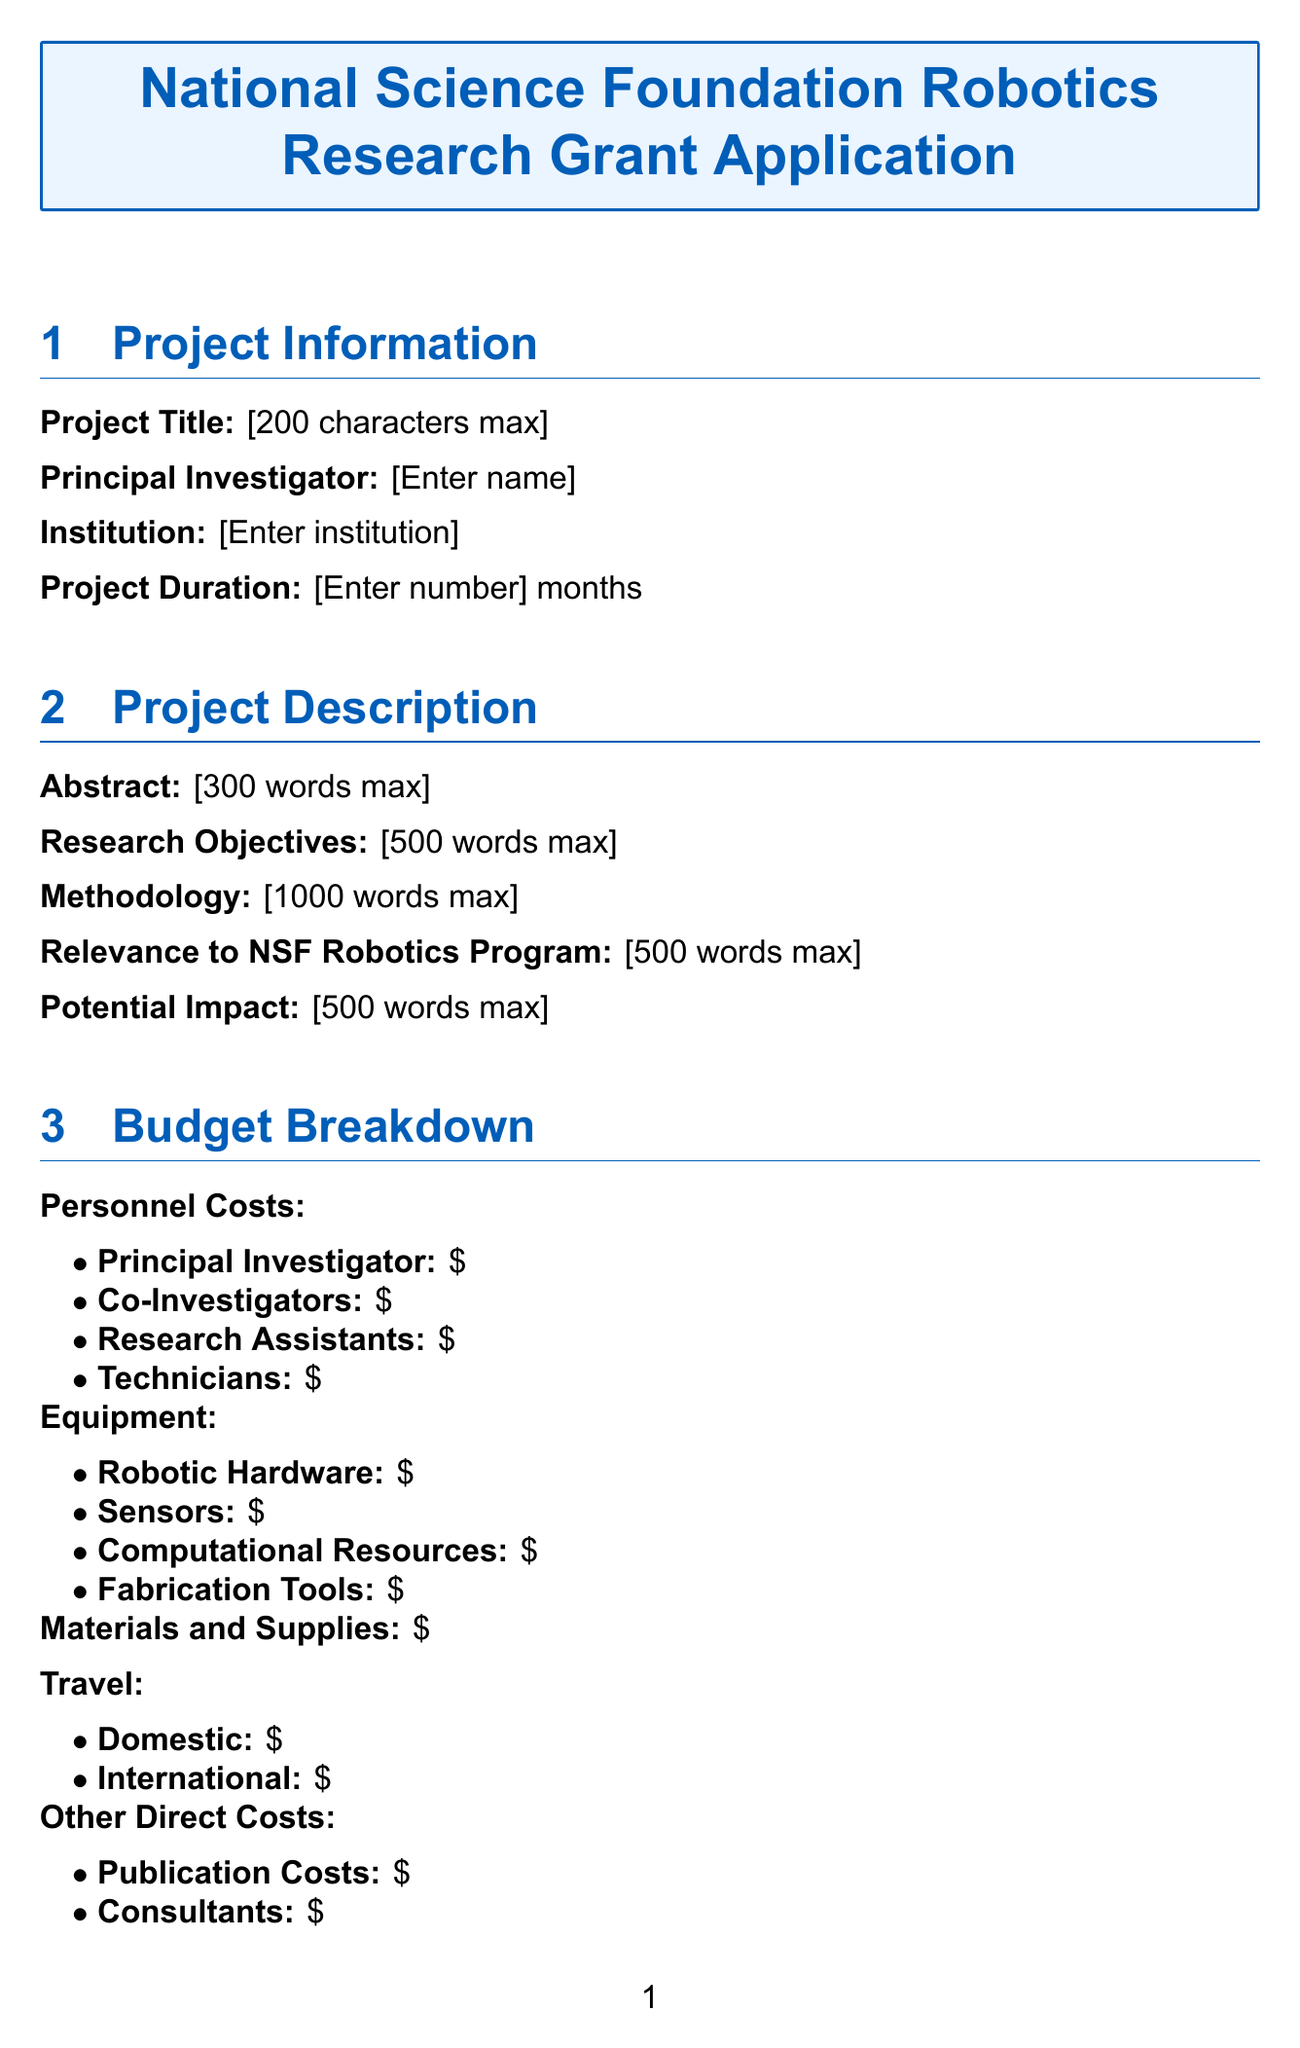what is the deadline for submission? The deadline for submission is indicated in the submission guidelines section.
Answer: September 15, 2023 what platform should the application be submitted on? The submission platform is mentioned in the submission guidelines section.
Answer: NSF FastLane System who is the principal investigator? The principal investigator's name is requested in the project information section.
Answer: [Enter name] how many months is the project duration? The project duration is requested as a number in the project information section.
Answer: [Enter number] what are the total budget requested calculations based on? The total budget requested is calculated based on various components of the budget breakdown section.
Answer: Sum of all budget items what is the maximum word count for the abstract? The maximum word count for the abstract is specified under the project description section.
Answer: 300 words which evaluation criteria are listed for the grant applications? The evaluation criteria are outlined in the submission guidelines section.
Answer: Intellectual Merit, Broader Impacts, Feasibility, Innovation, Team Qualifications what type of file is required for the Data Management Plan? The format for the Data Management Plan is specified in the ethical considerations section.
Answer: .pdf file are there any anticipated breakthroughs mentioned? The availability of anticipated breakthroughs is specified in the expected outcomes section of the application.
Answer: [500 words max] 